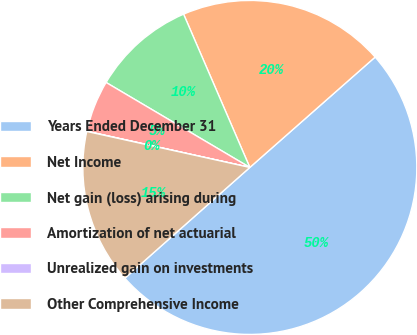Convert chart. <chart><loc_0><loc_0><loc_500><loc_500><pie_chart><fcel>Years Ended December 31<fcel>Net Income<fcel>Net gain (loss) arising during<fcel>Amortization of net actuarial<fcel>Unrealized gain on investments<fcel>Other Comprehensive Income<nl><fcel>49.95%<fcel>20.0%<fcel>10.01%<fcel>5.02%<fcel>0.02%<fcel>15.0%<nl></chart> 